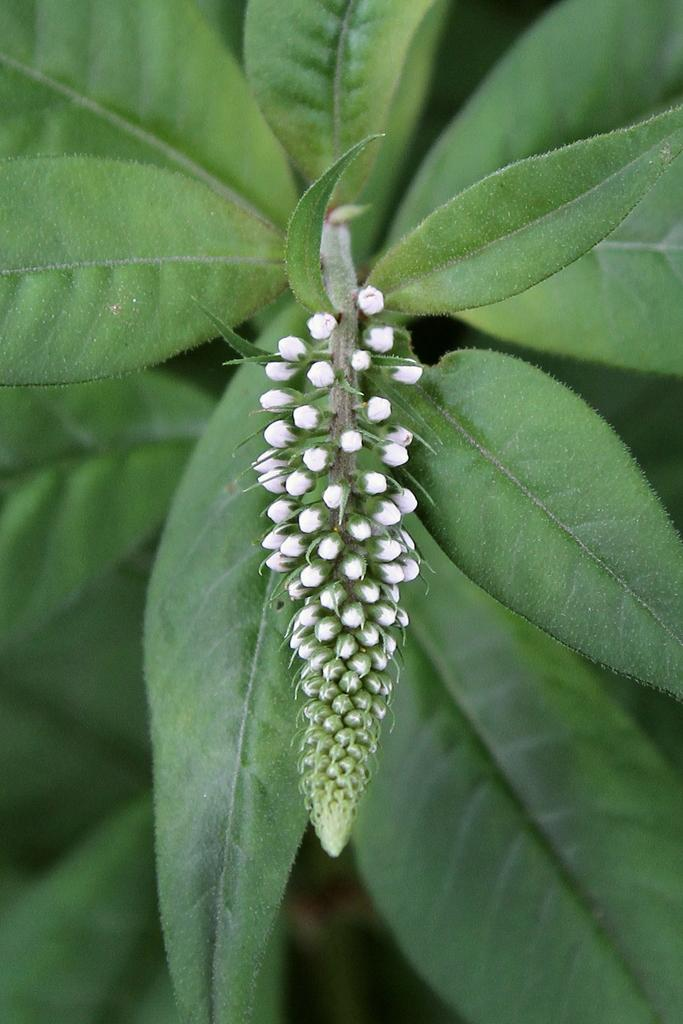What is present in the image? There is a plant in the image. Can you describe the flowers on the plant? The plant has small, tiny flowers. What else can be seen in the background of the image? There are green leaves in the background of the image. How does the lettuce in the image join the plant? There is no lettuce present in the image; it only features a plant with small, tiny flowers and green leaves in the background. 